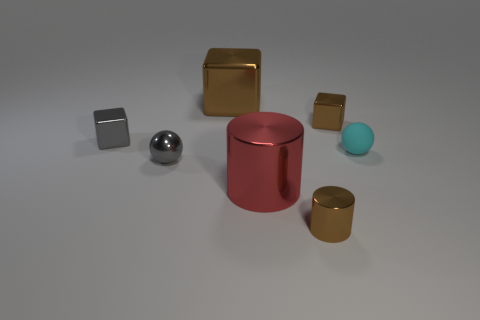Subtract all small brown metal cubes. How many cubes are left? 2 Subtract 2 cylinders. How many cylinders are left? 0 Subtract all gray balls. How many balls are left? 1 Add 2 small brown cubes. How many objects exist? 9 Subtract all cubes. How many objects are left? 4 Subtract all purple cylinders. How many brown blocks are left? 2 Subtract all large brown cubes. Subtract all matte objects. How many objects are left? 5 Add 7 gray cubes. How many gray cubes are left? 8 Add 1 rubber spheres. How many rubber spheres exist? 2 Subtract 0 green cubes. How many objects are left? 7 